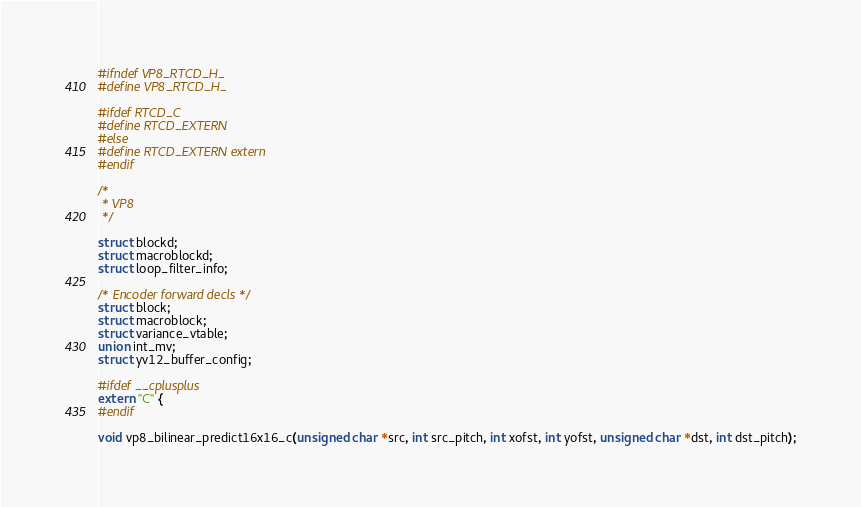<code> <loc_0><loc_0><loc_500><loc_500><_C_>#ifndef VP8_RTCD_H_
#define VP8_RTCD_H_

#ifdef RTCD_C
#define RTCD_EXTERN
#else
#define RTCD_EXTERN extern
#endif

/*
 * VP8
 */

struct blockd;
struct macroblockd;
struct loop_filter_info;

/* Encoder forward decls */
struct block;
struct macroblock;
struct variance_vtable;
union int_mv;
struct yv12_buffer_config;

#ifdef __cplusplus
extern "C" {
#endif

void vp8_bilinear_predict16x16_c(unsigned char *src, int src_pitch, int xofst, int yofst, unsigned char *dst, int dst_pitch);</code> 